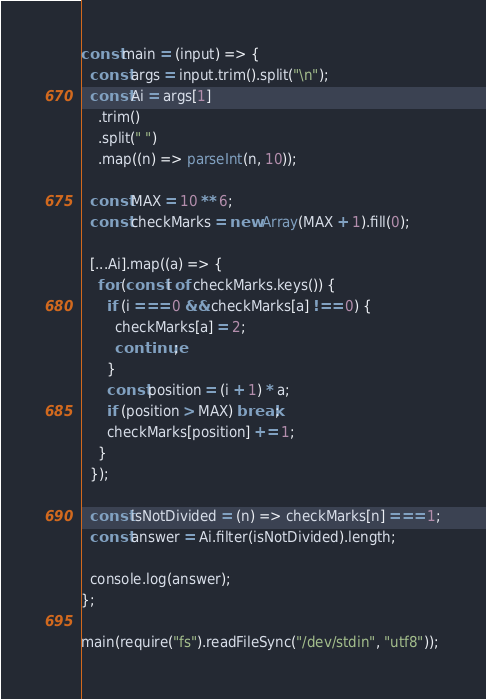<code> <loc_0><loc_0><loc_500><loc_500><_JavaScript_>const main = (input) => {
  const args = input.trim().split("\n");
  const Ai = args[1]
    .trim()
    .split(" ")
    .map((n) => parseInt(n, 10));

  const MAX = 10 ** 6;
  const checkMarks = new Array(MAX + 1).fill(0);

  [...Ai].map((a) => {
    for (const i of checkMarks.keys()) {
      if (i === 0 && checkMarks[a] !== 0) {
        checkMarks[a] = 2;
        continue;
      }
      const position = (i + 1) * a;
      if (position > MAX) break;
      checkMarks[position] += 1;
    }
  });

  const isNotDivided = (n) => checkMarks[n] === 1;
  const answer = Ai.filter(isNotDivided).length;

  console.log(answer);
};

main(require("fs").readFileSync("/dev/stdin", "utf8"));</code> 